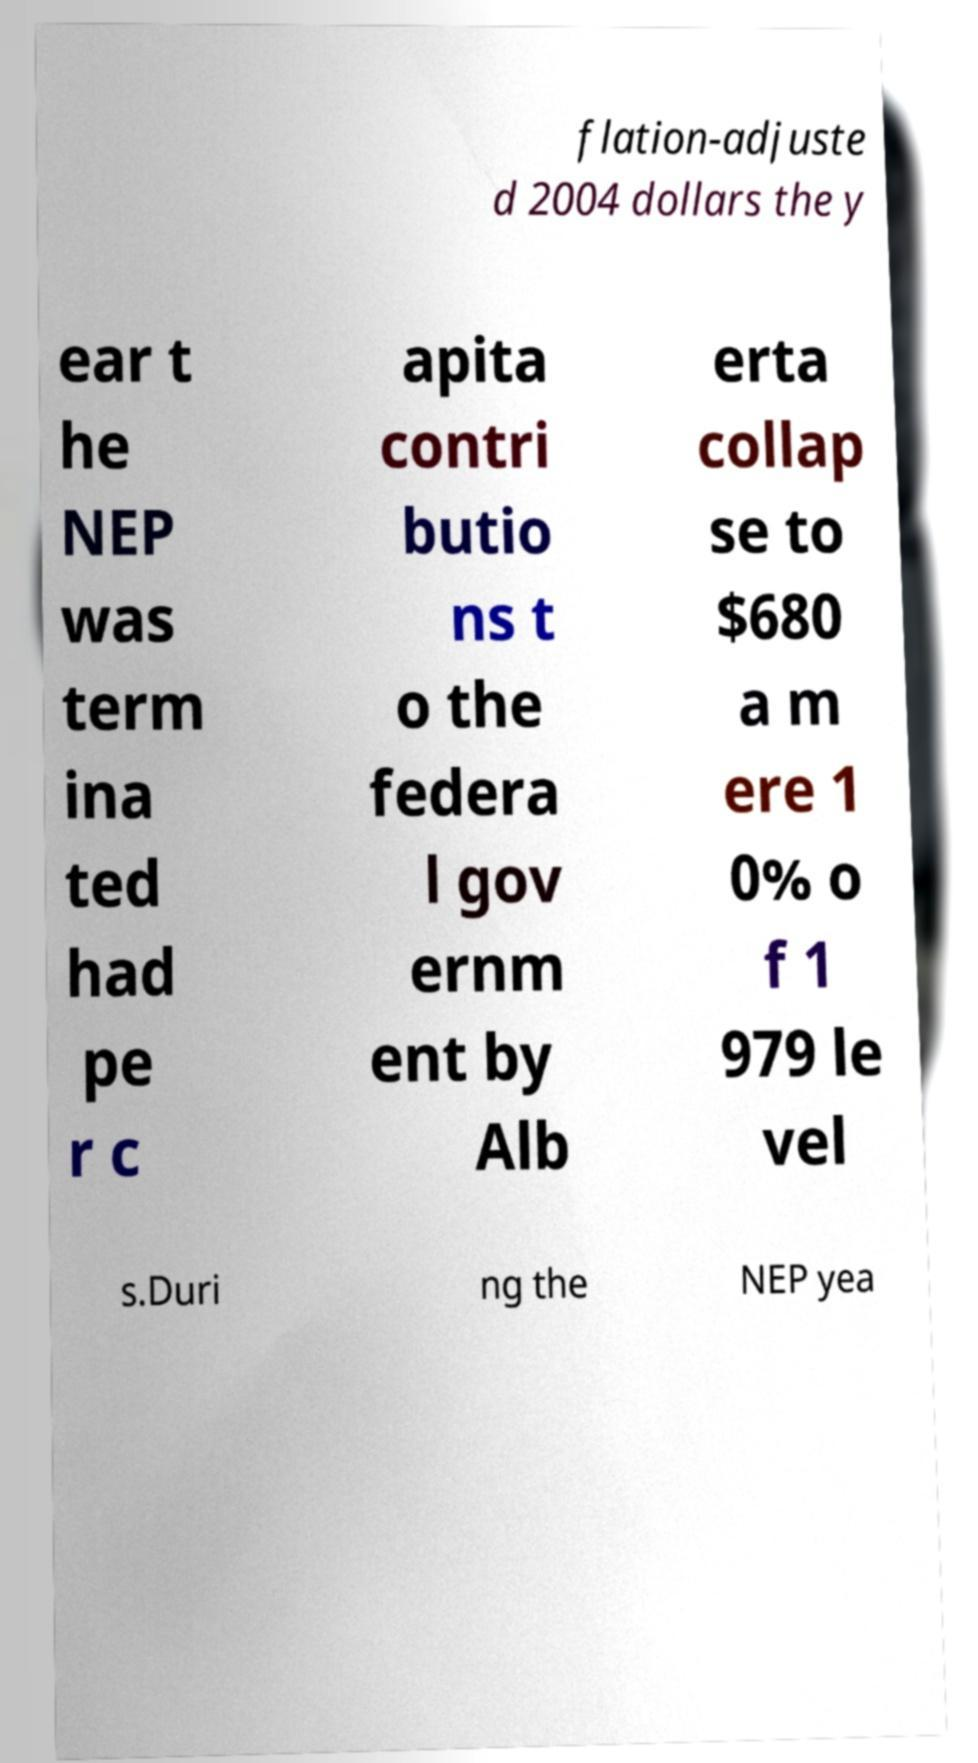For documentation purposes, I need the text within this image transcribed. Could you provide that? flation-adjuste d 2004 dollars the y ear t he NEP was term ina ted had pe r c apita contri butio ns t o the federa l gov ernm ent by Alb erta collap se to $680 a m ere 1 0% o f 1 979 le vel s.Duri ng the NEP yea 